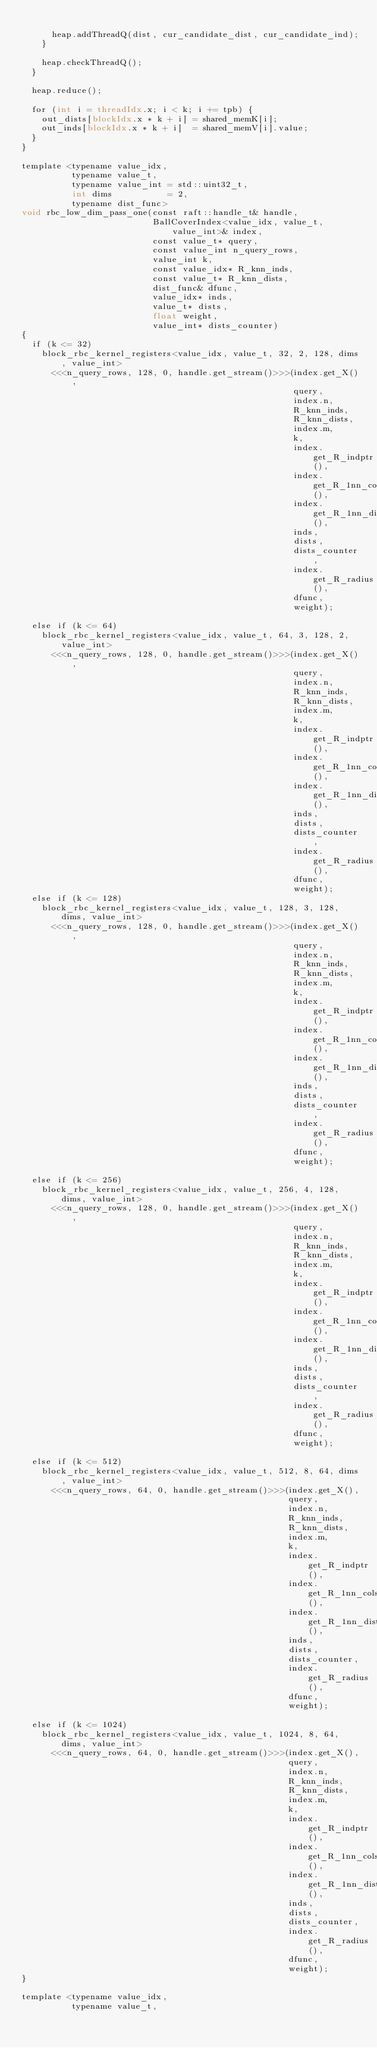<code> <loc_0><loc_0><loc_500><loc_500><_Cuda_>
      heap.addThreadQ(dist, cur_candidate_dist, cur_candidate_ind);
    }

    heap.checkThreadQ();
  }

  heap.reduce();

  for (int i = threadIdx.x; i < k; i += tpb) {
    out_dists[blockIdx.x * k + i] = shared_memK[i];
    out_inds[blockIdx.x * k + i]  = shared_memV[i].value;
  }
}

template <typename value_idx,
          typename value_t,
          typename value_int = std::uint32_t,
          int dims           = 2,
          typename dist_func>
void rbc_low_dim_pass_one(const raft::handle_t& handle,
                          BallCoverIndex<value_idx, value_t, value_int>& index,
                          const value_t* query,
                          const value_int n_query_rows,
                          value_int k,
                          const value_idx* R_knn_inds,
                          const value_t* R_knn_dists,
                          dist_func& dfunc,
                          value_idx* inds,
                          value_t* dists,
                          float weight,
                          value_int* dists_counter)
{
  if (k <= 32)
    block_rbc_kernel_registers<value_idx, value_t, 32, 2, 128, dims, value_int>
      <<<n_query_rows, 128, 0, handle.get_stream()>>>(index.get_X(),
                                                      query,
                                                      index.n,
                                                      R_knn_inds,
                                                      R_knn_dists,
                                                      index.m,
                                                      k,
                                                      index.get_R_indptr(),
                                                      index.get_R_1nn_cols(),
                                                      index.get_R_1nn_dists(),
                                                      inds,
                                                      dists,
                                                      dists_counter,
                                                      index.get_R_radius(),
                                                      dfunc,
                                                      weight);

  else if (k <= 64)
    block_rbc_kernel_registers<value_idx, value_t, 64, 3, 128, 2, value_int>
      <<<n_query_rows, 128, 0, handle.get_stream()>>>(index.get_X(),
                                                      query,
                                                      index.n,
                                                      R_knn_inds,
                                                      R_knn_dists,
                                                      index.m,
                                                      k,
                                                      index.get_R_indptr(),
                                                      index.get_R_1nn_cols(),
                                                      index.get_R_1nn_dists(),
                                                      inds,
                                                      dists,
                                                      dists_counter,
                                                      index.get_R_radius(),
                                                      dfunc,
                                                      weight);
  else if (k <= 128)
    block_rbc_kernel_registers<value_idx, value_t, 128, 3, 128, dims, value_int>
      <<<n_query_rows, 128, 0, handle.get_stream()>>>(index.get_X(),
                                                      query,
                                                      index.n,
                                                      R_knn_inds,
                                                      R_knn_dists,
                                                      index.m,
                                                      k,
                                                      index.get_R_indptr(),
                                                      index.get_R_1nn_cols(),
                                                      index.get_R_1nn_dists(),
                                                      inds,
                                                      dists,
                                                      dists_counter,
                                                      index.get_R_radius(),
                                                      dfunc,
                                                      weight);

  else if (k <= 256)
    block_rbc_kernel_registers<value_idx, value_t, 256, 4, 128, dims, value_int>
      <<<n_query_rows, 128, 0, handle.get_stream()>>>(index.get_X(),
                                                      query,
                                                      index.n,
                                                      R_knn_inds,
                                                      R_knn_dists,
                                                      index.m,
                                                      k,
                                                      index.get_R_indptr(),
                                                      index.get_R_1nn_cols(),
                                                      index.get_R_1nn_dists(),
                                                      inds,
                                                      dists,
                                                      dists_counter,
                                                      index.get_R_radius(),
                                                      dfunc,
                                                      weight);

  else if (k <= 512)
    block_rbc_kernel_registers<value_idx, value_t, 512, 8, 64, dims, value_int>
      <<<n_query_rows, 64, 0, handle.get_stream()>>>(index.get_X(),
                                                     query,
                                                     index.n,
                                                     R_knn_inds,
                                                     R_knn_dists,
                                                     index.m,
                                                     k,
                                                     index.get_R_indptr(),
                                                     index.get_R_1nn_cols(),
                                                     index.get_R_1nn_dists(),
                                                     inds,
                                                     dists,
                                                     dists_counter,
                                                     index.get_R_radius(),
                                                     dfunc,
                                                     weight);

  else if (k <= 1024)
    block_rbc_kernel_registers<value_idx, value_t, 1024, 8, 64, dims, value_int>
      <<<n_query_rows, 64, 0, handle.get_stream()>>>(index.get_X(),
                                                     query,
                                                     index.n,
                                                     R_knn_inds,
                                                     R_knn_dists,
                                                     index.m,
                                                     k,
                                                     index.get_R_indptr(),
                                                     index.get_R_1nn_cols(),
                                                     index.get_R_1nn_dists(),
                                                     inds,
                                                     dists,
                                                     dists_counter,
                                                     index.get_R_radius(),
                                                     dfunc,
                                                     weight);
}

template <typename value_idx,
          typename value_t,</code> 